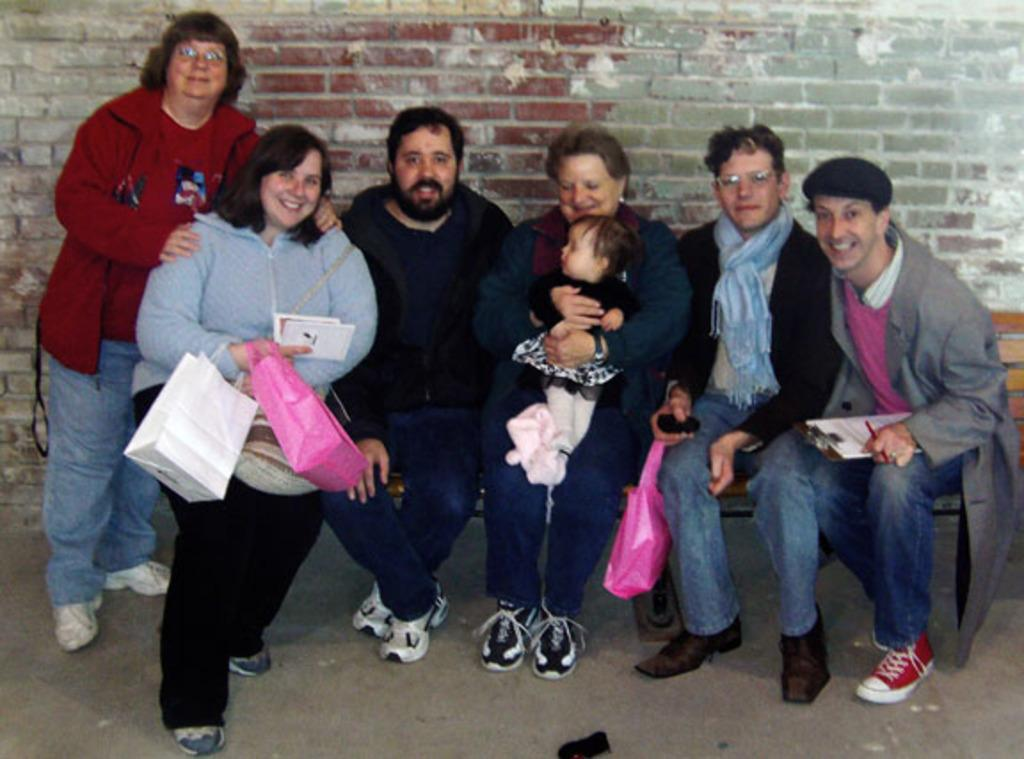How many persons can be seen in the image? There are persons in the image. What are the persons holding in their hands? Two persons are holding bags with their hands. What can be seen in the background of the image? There is a wall in the background of the image. How many mice are visible in the image? There are no mice present in the image. What type of truck can be seen in the image? There is no truck present in the image. 